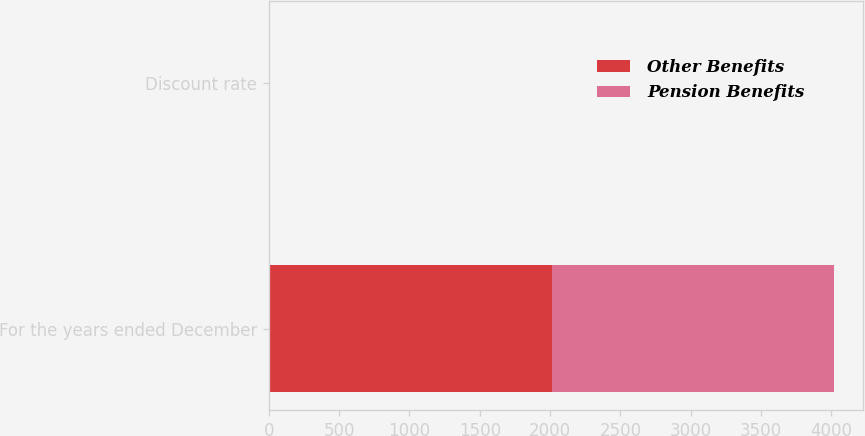Convert chart to OTSL. <chart><loc_0><loc_0><loc_500><loc_500><stacked_bar_chart><ecel><fcel>For the years ended December<fcel>Discount rate<nl><fcel>Other Benefits<fcel>2011<fcel>5.2<nl><fcel>Pension Benefits<fcel>2011<fcel>5.2<nl></chart> 